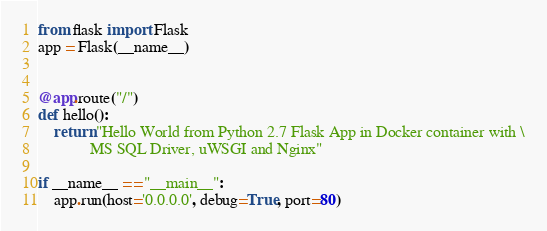Convert code to text. <code><loc_0><loc_0><loc_500><loc_500><_Python_>from flask import Flask
app = Flask(__name__)


@app.route("/")
def hello():
    return "Hello World from Python 2.7 Flask App in Docker container with \
     	     MS SQL Driver, uWSGI and Nginx"

if __name__ == "__main__":
    app.run(host='0.0.0.0', debug=True, port=80)
</code> 